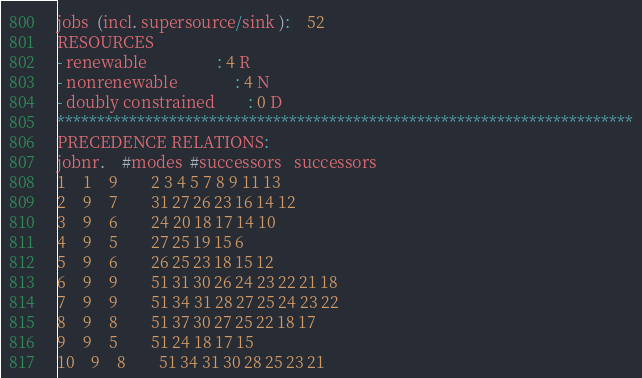<code> <loc_0><loc_0><loc_500><loc_500><_ObjectiveC_>jobs  (incl. supersource/sink ):	52
RESOURCES
- renewable                 : 4 R
- nonrenewable              : 4 N
- doubly constrained        : 0 D
************************************************************************
PRECEDENCE RELATIONS:
jobnr.    #modes  #successors   successors
1	1	9		2 3 4 5 7 8 9 11 13 
2	9	7		31 27 26 23 16 14 12 
3	9	6		24 20 18 17 14 10 
4	9	5		27 25 19 15 6 
5	9	6		26 25 23 18 15 12 
6	9	9		51 31 30 26 24 23 22 21 18 
7	9	9		51 34 31 28 27 25 24 23 22 
8	9	8		51 37 30 27 25 22 18 17 
9	9	5		51 24 18 17 15 
10	9	8		51 34 31 30 28 25 23 21 </code> 